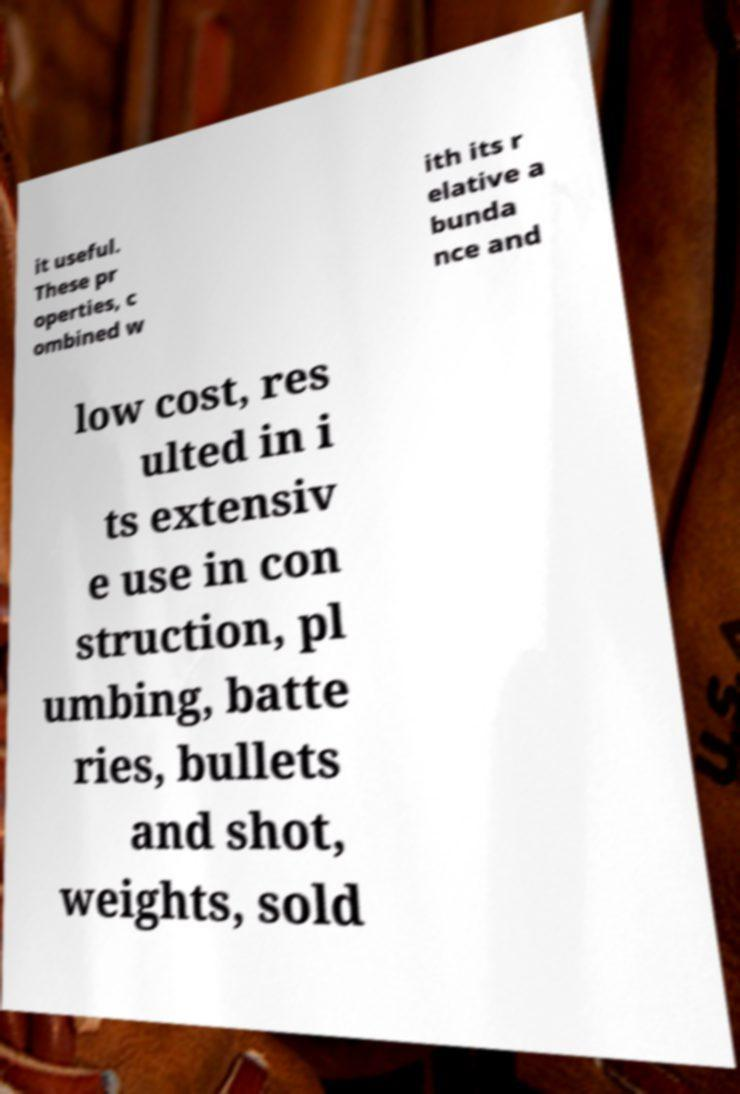Can you read and provide the text displayed in the image?This photo seems to have some interesting text. Can you extract and type it out for me? it useful. These pr operties, c ombined w ith its r elative a bunda nce and low cost, res ulted in i ts extensiv e use in con struction, pl umbing, batte ries, bullets and shot, weights, sold 